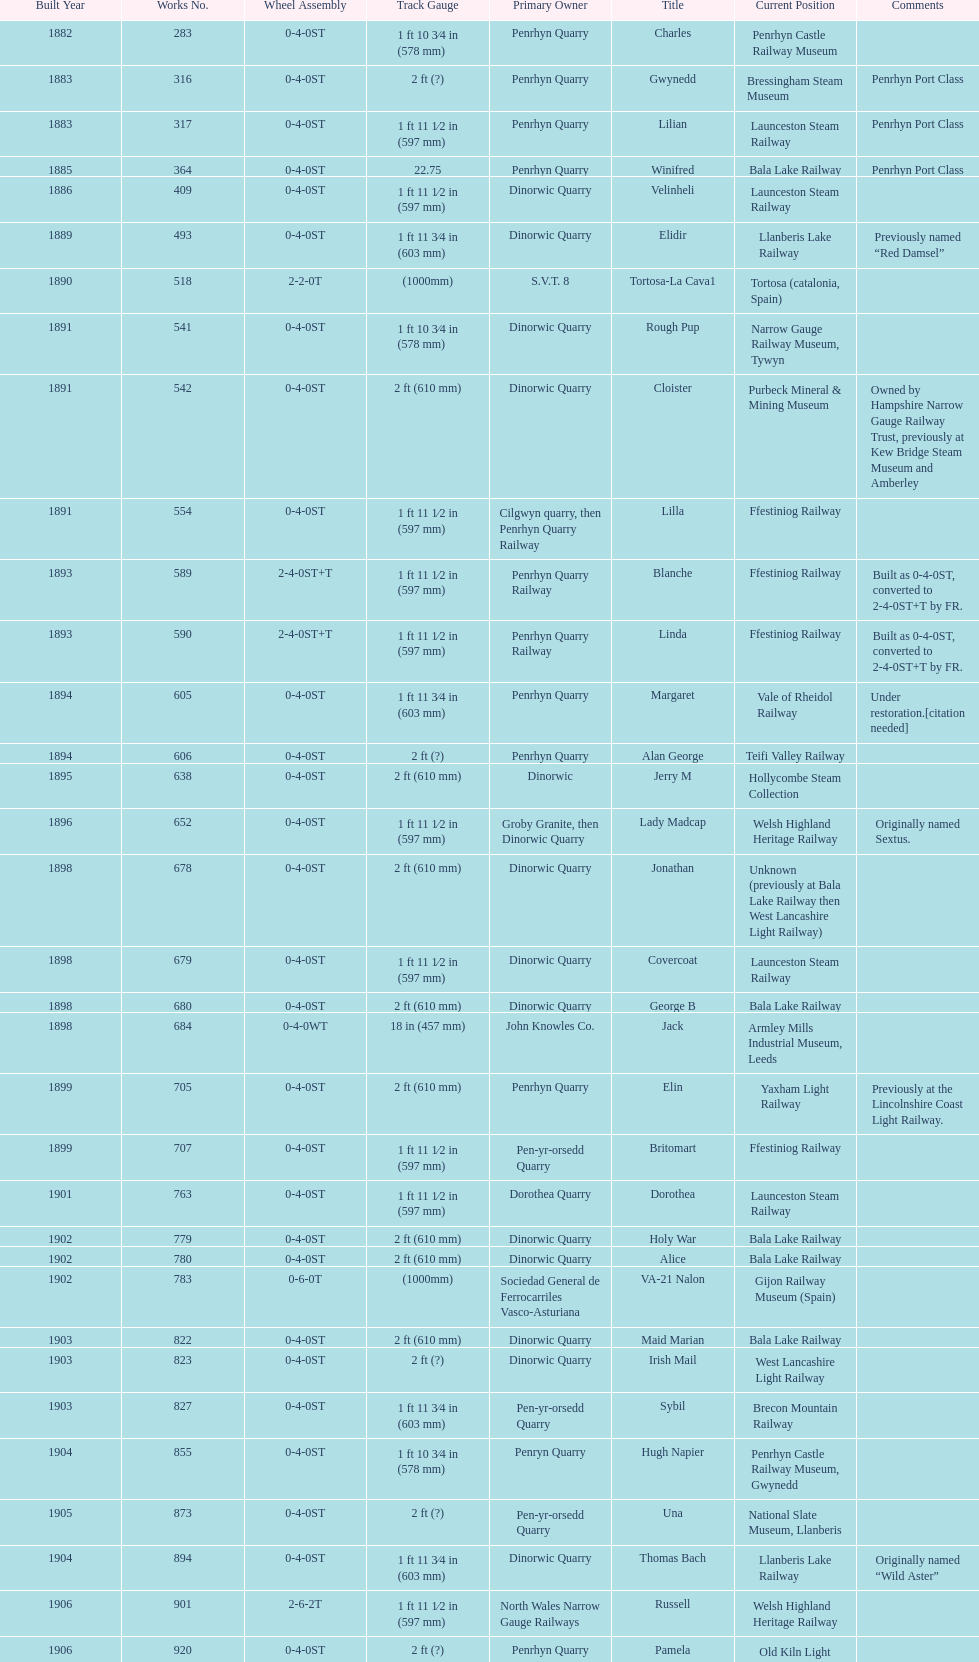How many steam locomotives are currently located at the bala lake railway? 364. 